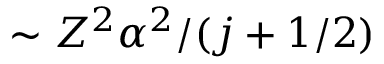<formula> <loc_0><loc_0><loc_500><loc_500>\sim Z ^ { 2 } \alpha ^ { 2 } / ( j + 1 / 2 )</formula> 